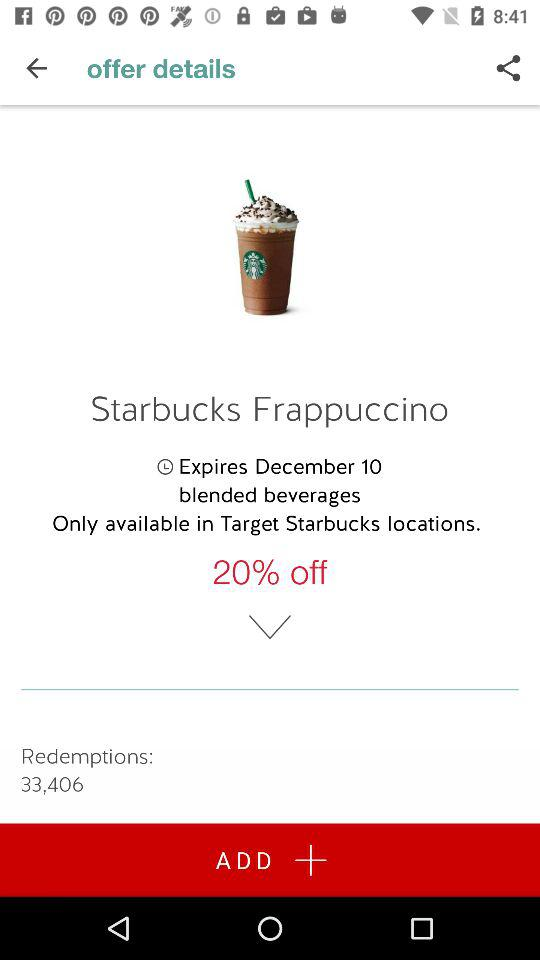What is the expiry date for the "Starbucks Frappuccino"? The expiry date for the "Starbucks Frappuccino" is December 10. 